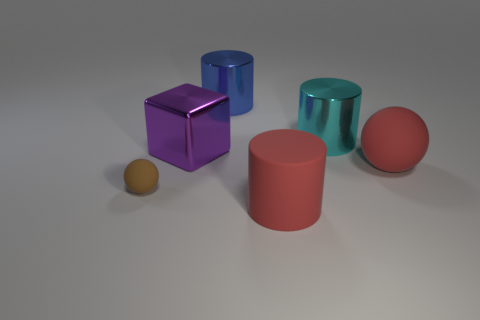Are there any large red things that have the same material as the purple cube?
Give a very brief answer. No. There is a cylinder that is the same color as the large ball; what is its size?
Ensure brevity in your answer.  Large. What number of cubes are either tiny things or purple metallic things?
Offer a very short reply. 1. Is the number of large metal cylinders in front of the purple metal cube greater than the number of small brown matte things that are right of the cyan thing?
Offer a very short reply. No. What number of cylinders have the same color as the small object?
Make the answer very short. 0. There is a brown object that is made of the same material as the big ball; what size is it?
Make the answer very short. Small. What number of objects are large red things behind the brown thing or big blue objects?
Keep it short and to the point. 2. Do the large thing that is in front of the big red rubber sphere and the big ball have the same color?
Your answer should be compact. Yes. There is a big metal cylinder that is in front of the object behind the cyan shiny cylinder that is right of the large purple cube; what is its color?
Make the answer very short. Cyan. Are the small brown ball and the red ball made of the same material?
Make the answer very short. Yes. 